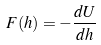Convert formula to latex. <formula><loc_0><loc_0><loc_500><loc_500>F ( h ) = - \frac { d U } { d h }</formula> 